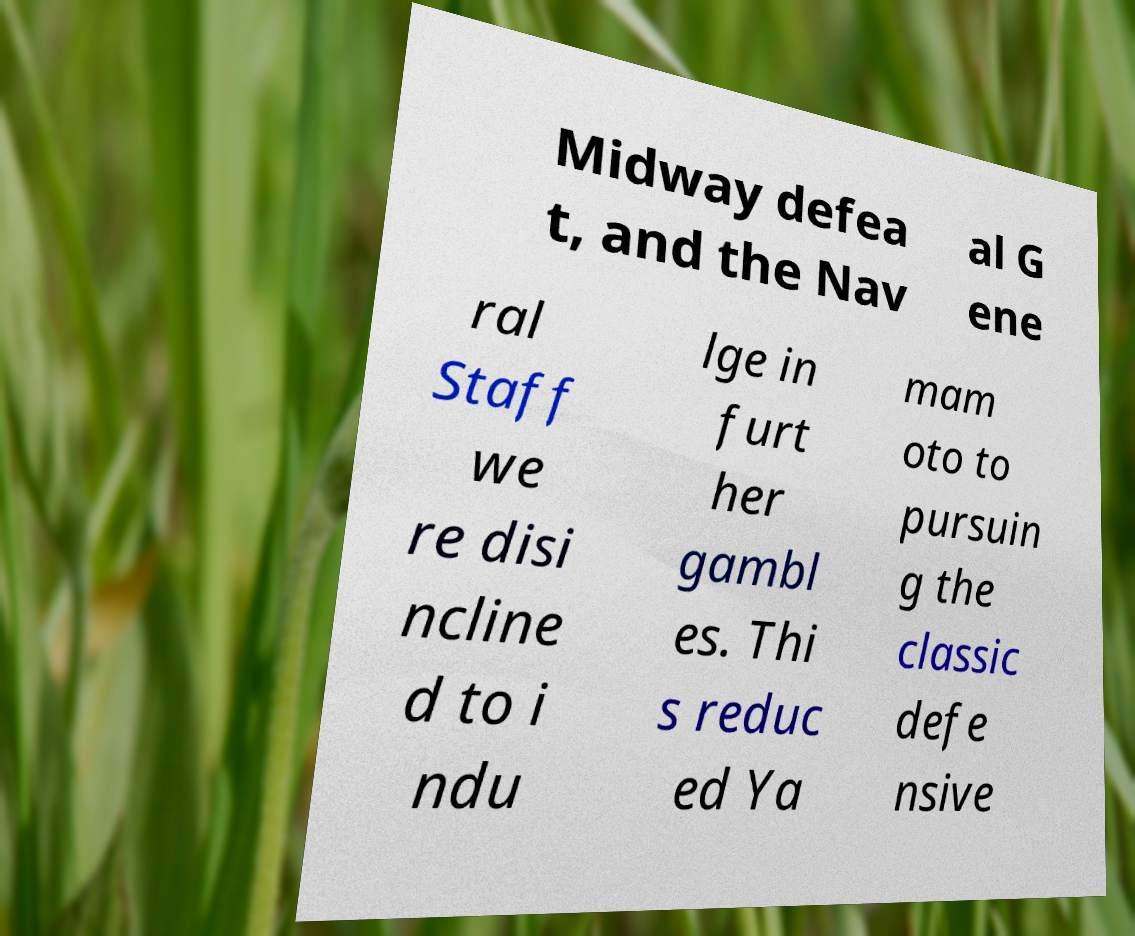Can you accurately transcribe the text from the provided image for me? Midway defea t, and the Nav al G ene ral Staff we re disi ncline d to i ndu lge in furt her gambl es. Thi s reduc ed Ya mam oto to pursuin g the classic defe nsive 